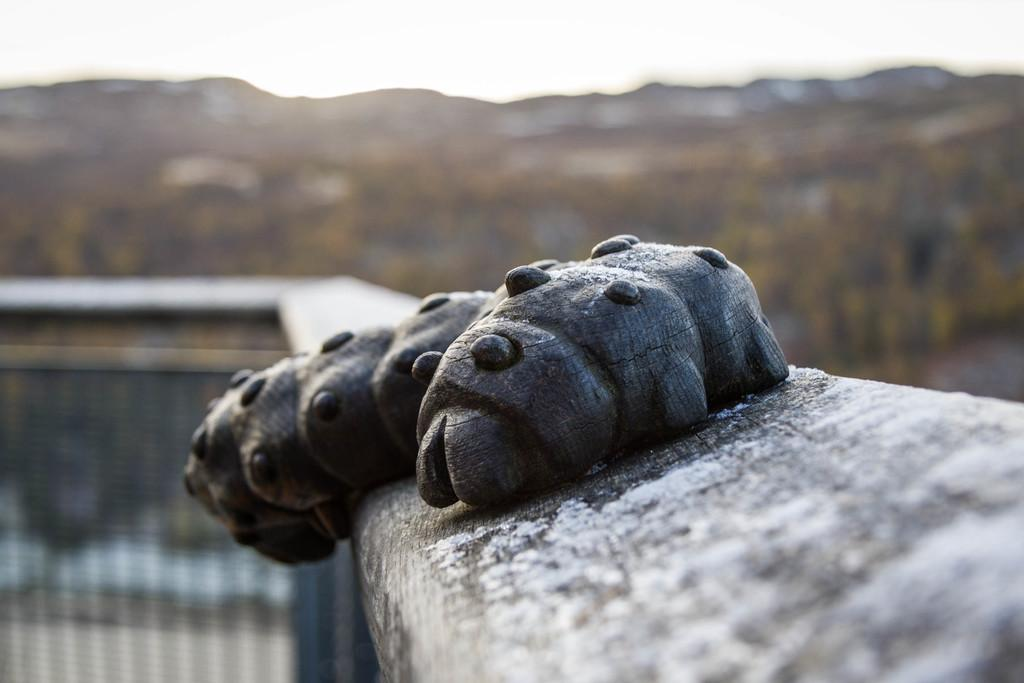What is placed on the fence in the image? There is an object placed on the fence. What can be seen in the background of the image? The sky is visible in the image. What type of vegetation is present in the image? There are plants in the image. What type of news can be heard coming from the object on the fence? There is no indication in the image that the object on the fence is related to news or that any sounds are being produced. 